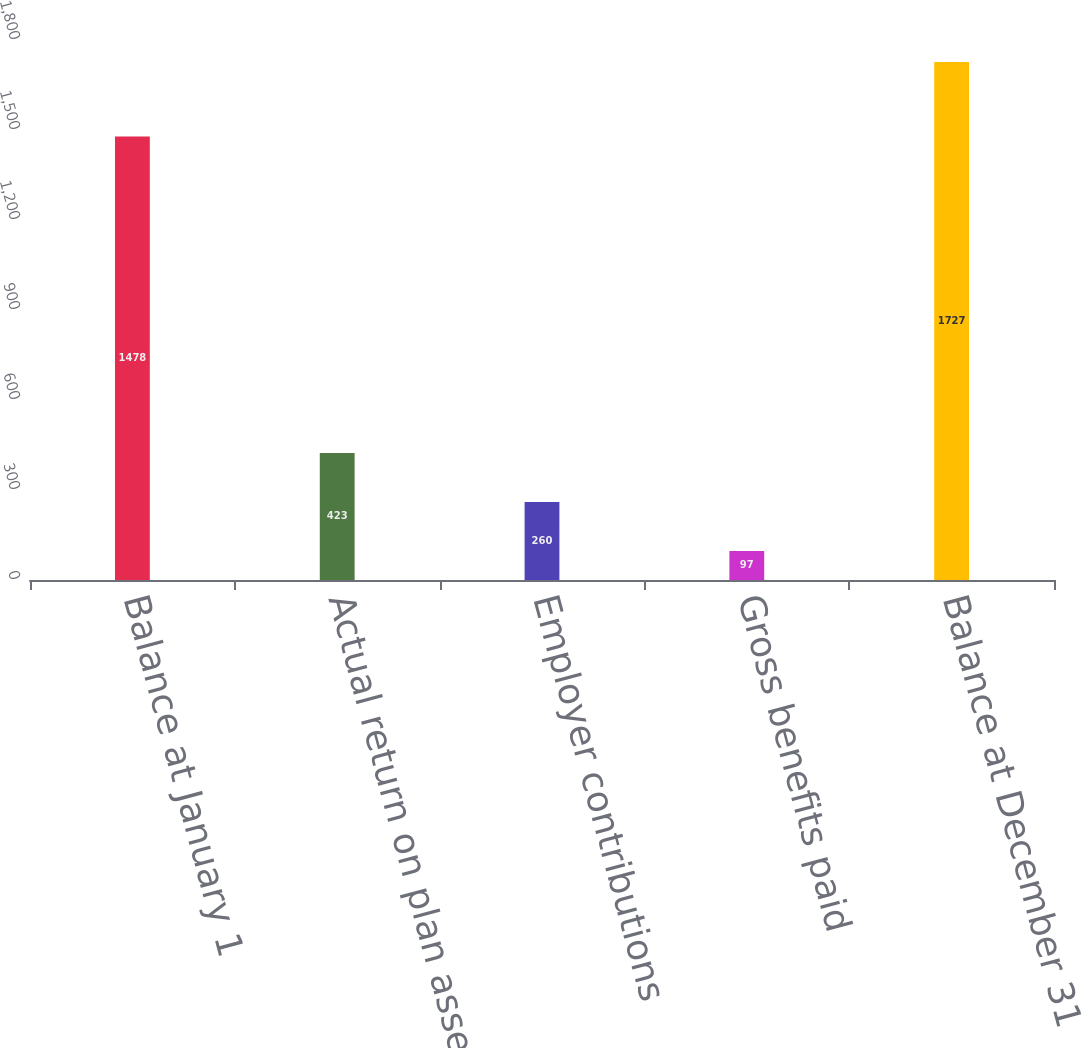Convert chart. <chart><loc_0><loc_0><loc_500><loc_500><bar_chart><fcel>Balance at January 1<fcel>Actual return on plan assets<fcel>Employer contributions<fcel>Gross benefits paid<fcel>Balance at December 31<nl><fcel>1478<fcel>423<fcel>260<fcel>97<fcel>1727<nl></chart> 